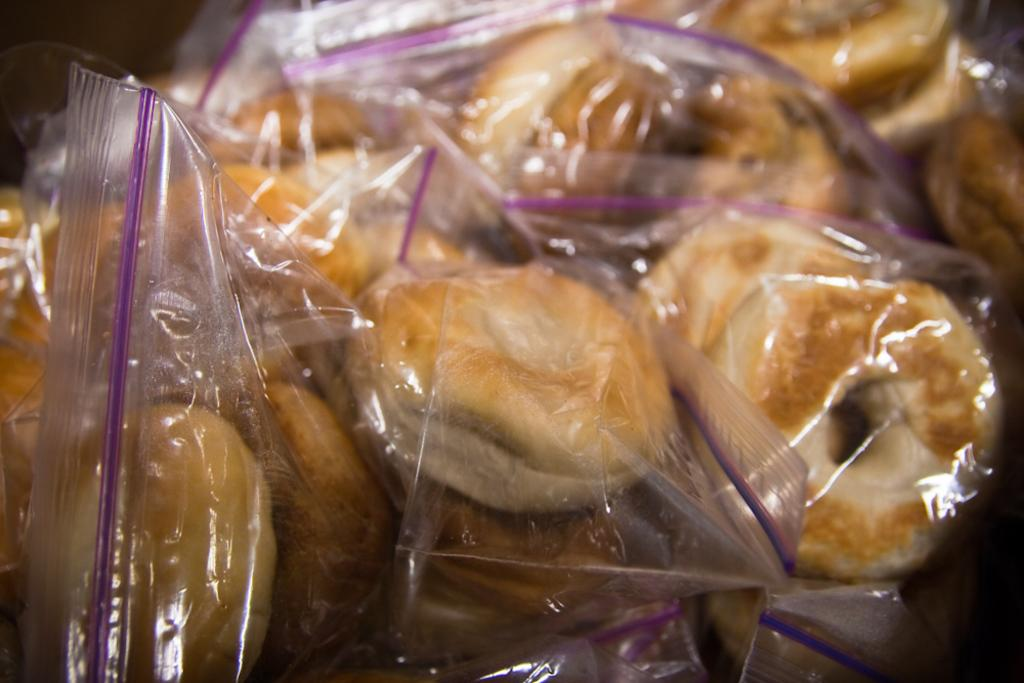What type of food is visible in the image? There are doughnuts in the image. How are the doughnuts arranged or presented in the image? The doughnuts are packed in the image. What type of suit is the egg wearing in the image? There is no egg or suit present in the image. Can you describe the ocean in the image? There is no ocean present in the image; it features doughnuts that are packed. 